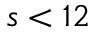<formula> <loc_0><loc_0><loc_500><loc_500>s < 1 2</formula> 